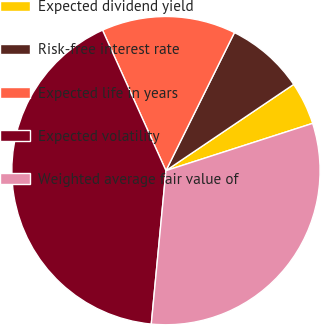Convert chart to OTSL. <chart><loc_0><loc_0><loc_500><loc_500><pie_chart><fcel>Expected dividend yield<fcel>Risk-free interest rate<fcel>Expected life in years<fcel>Expected volatility<fcel>Weighted average fair value of<nl><fcel>4.49%<fcel>8.22%<fcel>14.08%<fcel>41.74%<fcel>31.48%<nl></chart> 